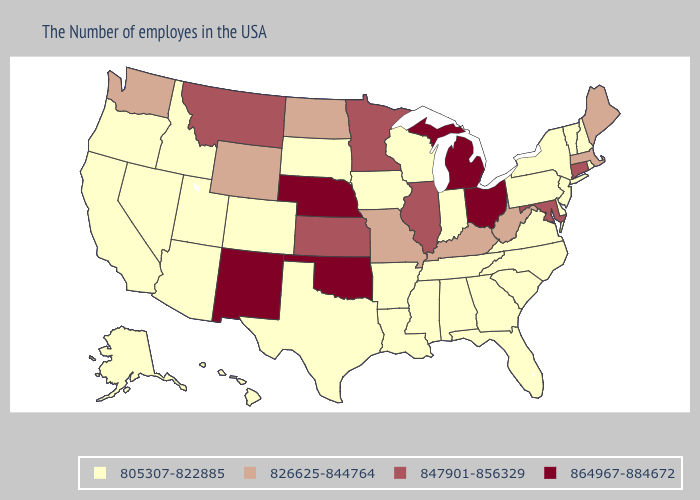Name the states that have a value in the range 864967-884672?
Answer briefly. Ohio, Michigan, Nebraska, Oklahoma, New Mexico. Among the states that border New Hampshire , does Vermont have the highest value?
Give a very brief answer. No. Among the states that border New York , which have the lowest value?
Give a very brief answer. Vermont, New Jersey, Pennsylvania. Among the states that border Alabama , which have the lowest value?
Write a very short answer. Florida, Georgia, Tennessee, Mississippi. What is the lowest value in the MidWest?
Concise answer only. 805307-822885. Name the states that have a value in the range 864967-884672?
Short answer required. Ohio, Michigan, Nebraska, Oklahoma, New Mexico. Does Alabama have the lowest value in the South?
Keep it brief. Yes. Among the states that border Connecticut , which have the highest value?
Give a very brief answer. Massachusetts. Does the first symbol in the legend represent the smallest category?
Concise answer only. Yes. Which states hav the highest value in the South?
Be succinct. Oklahoma. Which states have the highest value in the USA?
Short answer required. Ohio, Michigan, Nebraska, Oklahoma, New Mexico. What is the highest value in states that border Connecticut?
Answer briefly. 826625-844764. Which states hav the highest value in the South?
Quick response, please. Oklahoma. Does Kentucky have the lowest value in the USA?
Give a very brief answer. No. 